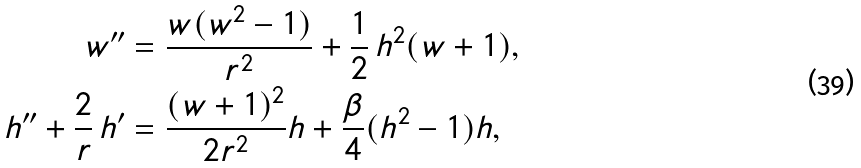Convert formula to latex. <formula><loc_0><loc_0><loc_500><loc_500>w ^ { \prime \prime } & = \frac { w ( w ^ { 2 } - 1 ) } { r ^ { 2 } } + \frac { 1 } { 2 } \, h ^ { 2 } ( w + 1 ) , \\ h ^ { \prime \prime } + \frac { 2 } { r } \, h ^ { \prime } & = \frac { ( w + 1 ) ^ { 2 } } { 2 r ^ { 2 } } h + \frac { \beta } { 4 } ( h ^ { 2 } - 1 ) h ,</formula> 